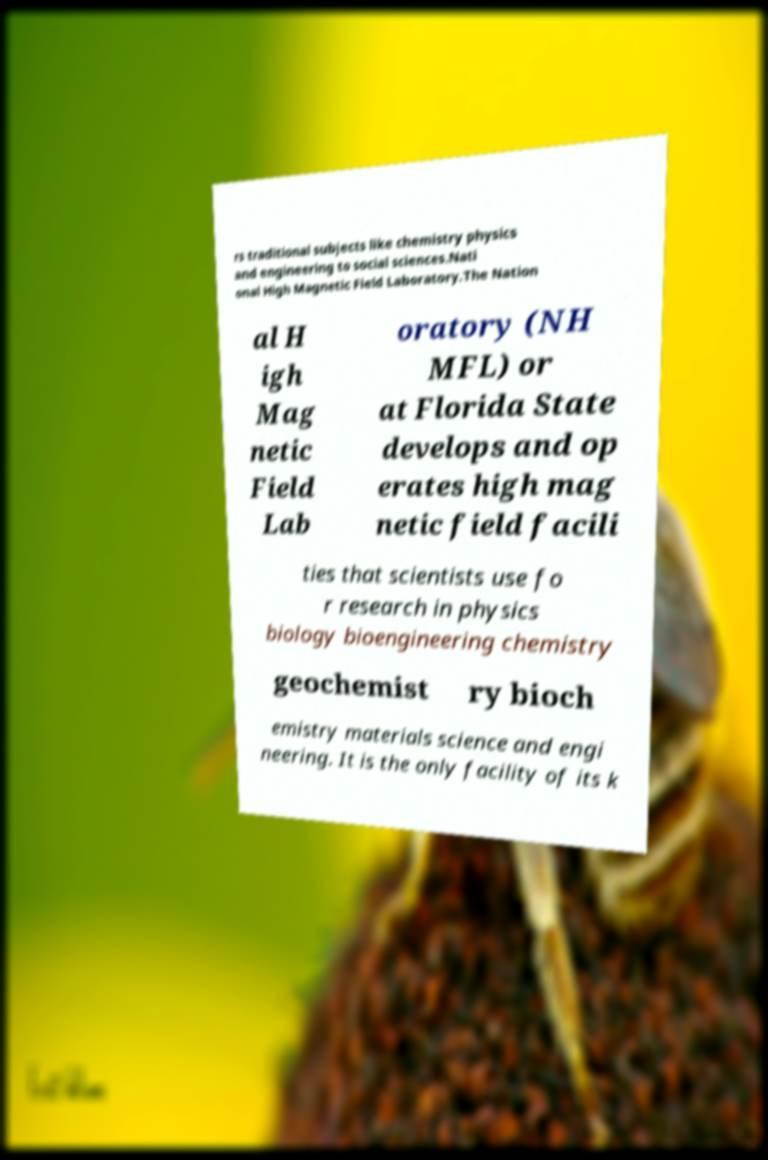Please identify and transcribe the text found in this image. rs traditional subjects like chemistry physics and engineering to social sciences.Nati onal High Magnetic Field Laboratory.The Nation al H igh Mag netic Field Lab oratory (NH MFL) or at Florida State develops and op erates high mag netic field facili ties that scientists use fo r research in physics biology bioengineering chemistry geochemist ry bioch emistry materials science and engi neering. It is the only facility of its k 